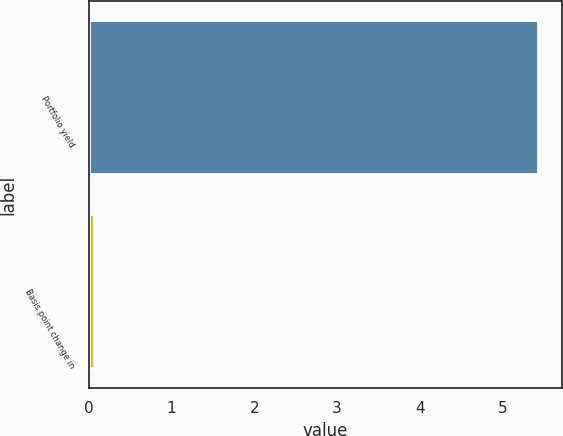<chart> <loc_0><loc_0><loc_500><loc_500><bar_chart><fcel>Portfolio yield<fcel>Basis point change in<nl><fcel>5.44<fcel>0.08<nl></chart> 